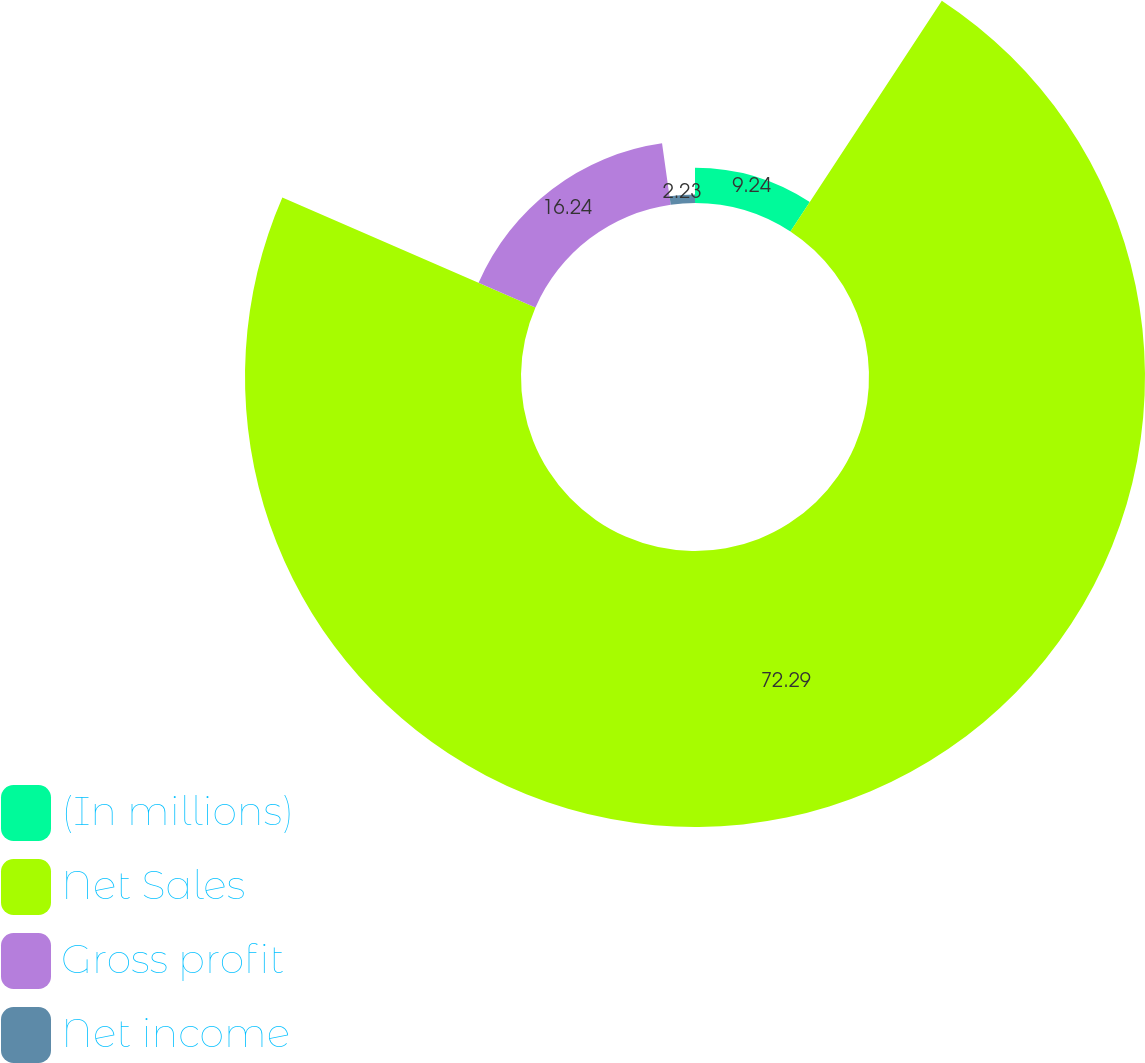Convert chart to OTSL. <chart><loc_0><loc_0><loc_500><loc_500><pie_chart><fcel>(In millions)<fcel>Net Sales<fcel>Gross profit<fcel>Net income<nl><fcel>9.24%<fcel>72.29%<fcel>16.24%<fcel>2.23%<nl></chart> 